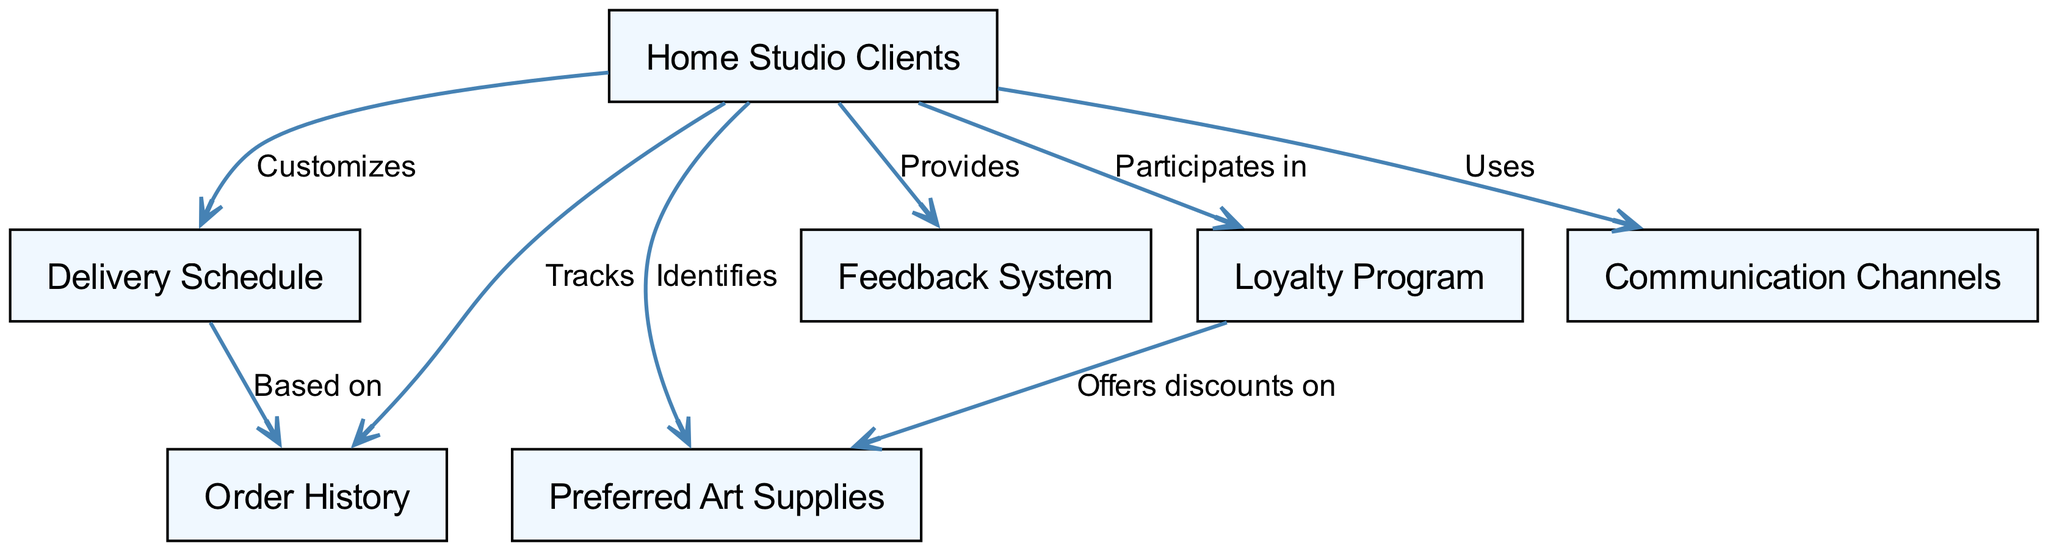What are the key components related to home studio clients? The diagram includes multiple nodes related to home studio clients, specifically: order history, preferred art supplies, delivery schedule, feedback system, loyalty program, and communication channels.
Answer: order history, preferred art supplies, delivery schedule, feedback system, loyalty program, communication channels How many relationships are tracked between nodes? The diagram contains six edges representing relationships between the nodes associated with home studio clients, showcasing how they interact with their order history, preferred supplies, delivery schedule, feedback system, loyalty program, and communication channels.
Answer: six Which program offers discounts on preferred supplies? The arrow leading from the loyalty program to preferred supplies indicates that the loyalty program provides discounts to home studio clients on their preferred art supplies.
Answer: loyalty program What does home studio clients provide to the feedback system? The edge from home studio clients to the feedback system shows that clients provide feedback to enhance customer relations.
Answer: feedback How does the delivery schedule relate to order history? The diagram indicates that the delivery schedule is based on the order history of home studio clients, suggesting that previous orders inform the timing of future deliveries.
Answer: based on Which communication channels do home studio clients use? The diagram states that home studio clients utilize communication channels; however, specific types of channels are not defined within the context of the map.
Answer: communication channels What can be customized for home studio clients? The diagram illustrates that the delivery schedule can be customized for home studio clients according to their specific needs and preferences.
Answer: delivery schedule What tracks the order history of home studio clients? The edge from home studio clients to order history indicates that it primarily tracks their previous orders and engagement with the supply service.
Answer: home studio clients 